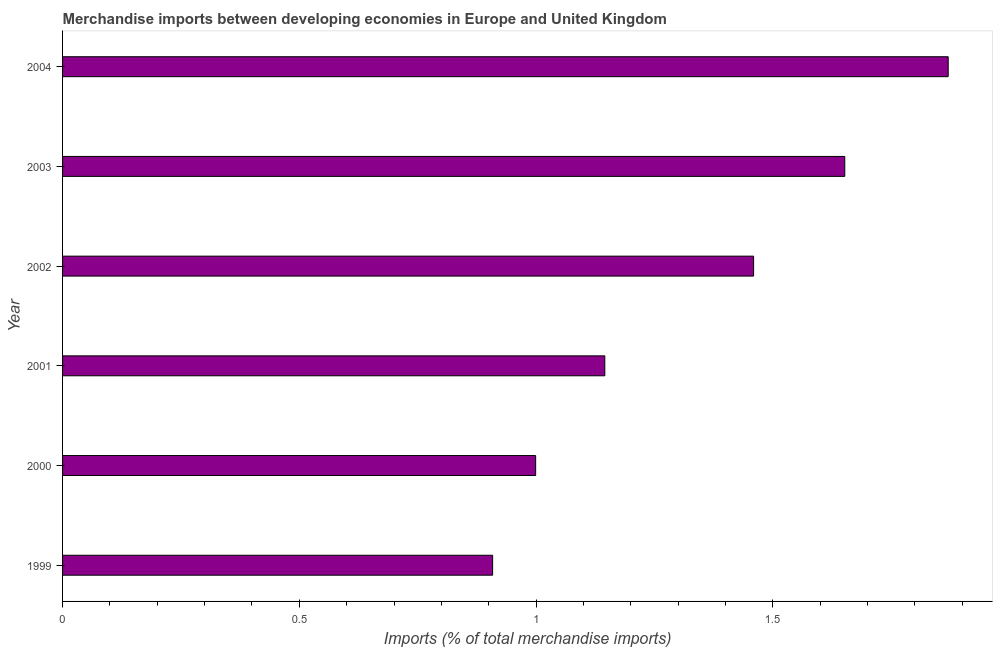Does the graph contain grids?
Offer a terse response. No. What is the title of the graph?
Offer a very short reply. Merchandise imports between developing economies in Europe and United Kingdom. What is the label or title of the X-axis?
Your answer should be compact. Imports (% of total merchandise imports). What is the label or title of the Y-axis?
Ensure brevity in your answer.  Year. What is the merchandise imports in 1999?
Keep it short and to the point. 0.91. Across all years, what is the maximum merchandise imports?
Give a very brief answer. 1.87. Across all years, what is the minimum merchandise imports?
Offer a very short reply. 0.91. In which year was the merchandise imports maximum?
Offer a terse response. 2004. In which year was the merchandise imports minimum?
Offer a terse response. 1999. What is the sum of the merchandise imports?
Ensure brevity in your answer.  8.03. What is the difference between the merchandise imports in 1999 and 2004?
Your answer should be compact. -0.96. What is the average merchandise imports per year?
Your answer should be compact. 1.34. What is the median merchandise imports?
Your response must be concise. 1.3. Do a majority of the years between 2002 and 2004 (inclusive) have merchandise imports greater than 0.1 %?
Offer a terse response. Yes. What is the ratio of the merchandise imports in 2003 to that in 2004?
Offer a terse response. 0.88. What is the difference between the highest and the second highest merchandise imports?
Your response must be concise. 0.22. Is the sum of the merchandise imports in 2001 and 2002 greater than the maximum merchandise imports across all years?
Your answer should be compact. Yes. Are all the bars in the graph horizontal?
Give a very brief answer. Yes. How many years are there in the graph?
Ensure brevity in your answer.  6. What is the Imports (% of total merchandise imports) in 1999?
Your answer should be compact. 0.91. What is the Imports (% of total merchandise imports) of 2000?
Keep it short and to the point. 1. What is the Imports (% of total merchandise imports) in 2001?
Provide a short and direct response. 1.15. What is the Imports (% of total merchandise imports) in 2002?
Keep it short and to the point. 1.46. What is the Imports (% of total merchandise imports) in 2003?
Your answer should be very brief. 1.65. What is the Imports (% of total merchandise imports) in 2004?
Your answer should be compact. 1.87. What is the difference between the Imports (% of total merchandise imports) in 1999 and 2000?
Provide a succinct answer. -0.09. What is the difference between the Imports (% of total merchandise imports) in 1999 and 2001?
Give a very brief answer. -0.24. What is the difference between the Imports (% of total merchandise imports) in 1999 and 2002?
Offer a terse response. -0.55. What is the difference between the Imports (% of total merchandise imports) in 1999 and 2003?
Provide a short and direct response. -0.74. What is the difference between the Imports (% of total merchandise imports) in 1999 and 2004?
Give a very brief answer. -0.96. What is the difference between the Imports (% of total merchandise imports) in 2000 and 2001?
Provide a succinct answer. -0.15. What is the difference between the Imports (% of total merchandise imports) in 2000 and 2002?
Give a very brief answer. -0.46. What is the difference between the Imports (% of total merchandise imports) in 2000 and 2003?
Provide a short and direct response. -0.65. What is the difference between the Imports (% of total merchandise imports) in 2000 and 2004?
Offer a terse response. -0.87. What is the difference between the Imports (% of total merchandise imports) in 2001 and 2002?
Your response must be concise. -0.31. What is the difference between the Imports (% of total merchandise imports) in 2001 and 2003?
Make the answer very short. -0.51. What is the difference between the Imports (% of total merchandise imports) in 2001 and 2004?
Your response must be concise. -0.73. What is the difference between the Imports (% of total merchandise imports) in 2002 and 2003?
Give a very brief answer. -0.19. What is the difference between the Imports (% of total merchandise imports) in 2002 and 2004?
Your answer should be compact. -0.41. What is the difference between the Imports (% of total merchandise imports) in 2003 and 2004?
Make the answer very short. -0.22. What is the ratio of the Imports (% of total merchandise imports) in 1999 to that in 2000?
Keep it short and to the point. 0.91. What is the ratio of the Imports (% of total merchandise imports) in 1999 to that in 2001?
Make the answer very short. 0.79. What is the ratio of the Imports (% of total merchandise imports) in 1999 to that in 2002?
Provide a succinct answer. 0.62. What is the ratio of the Imports (% of total merchandise imports) in 1999 to that in 2003?
Your answer should be compact. 0.55. What is the ratio of the Imports (% of total merchandise imports) in 1999 to that in 2004?
Provide a succinct answer. 0.49. What is the ratio of the Imports (% of total merchandise imports) in 2000 to that in 2001?
Your answer should be very brief. 0.87. What is the ratio of the Imports (% of total merchandise imports) in 2000 to that in 2002?
Offer a terse response. 0.69. What is the ratio of the Imports (% of total merchandise imports) in 2000 to that in 2003?
Make the answer very short. 0.6. What is the ratio of the Imports (% of total merchandise imports) in 2000 to that in 2004?
Give a very brief answer. 0.53. What is the ratio of the Imports (% of total merchandise imports) in 2001 to that in 2002?
Ensure brevity in your answer.  0.79. What is the ratio of the Imports (% of total merchandise imports) in 2001 to that in 2003?
Keep it short and to the point. 0.69. What is the ratio of the Imports (% of total merchandise imports) in 2001 to that in 2004?
Offer a terse response. 0.61. What is the ratio of the Imports (% of total merchandise imports) in 2002 to that in 2003?
Offer a terse response. 0.88. What is the ratio of the Imports (% of total merchandise imports) in 2002 to that in 2004?
Ensure brevity in your answer.  0.78. What is the ratio of the Imports (% of total merchandise imports) in 2003 to that in 2004?
Offer a terse response. 0.88. 